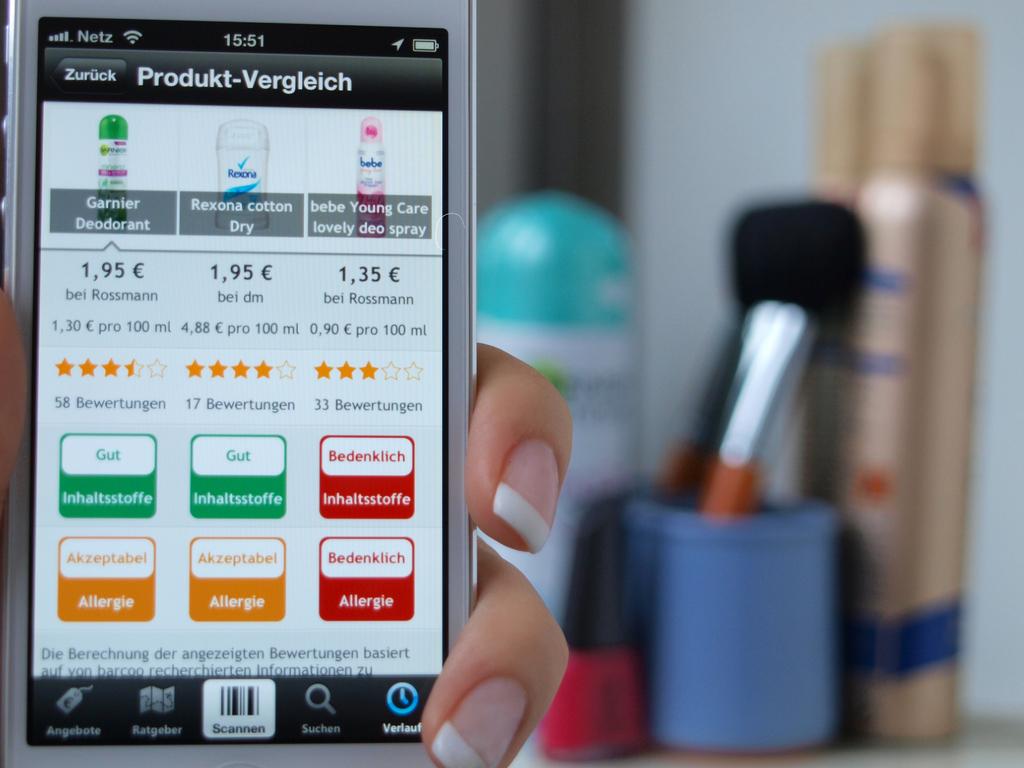What does the screen say?
Your response must be concise. Produkt-vergleich. 